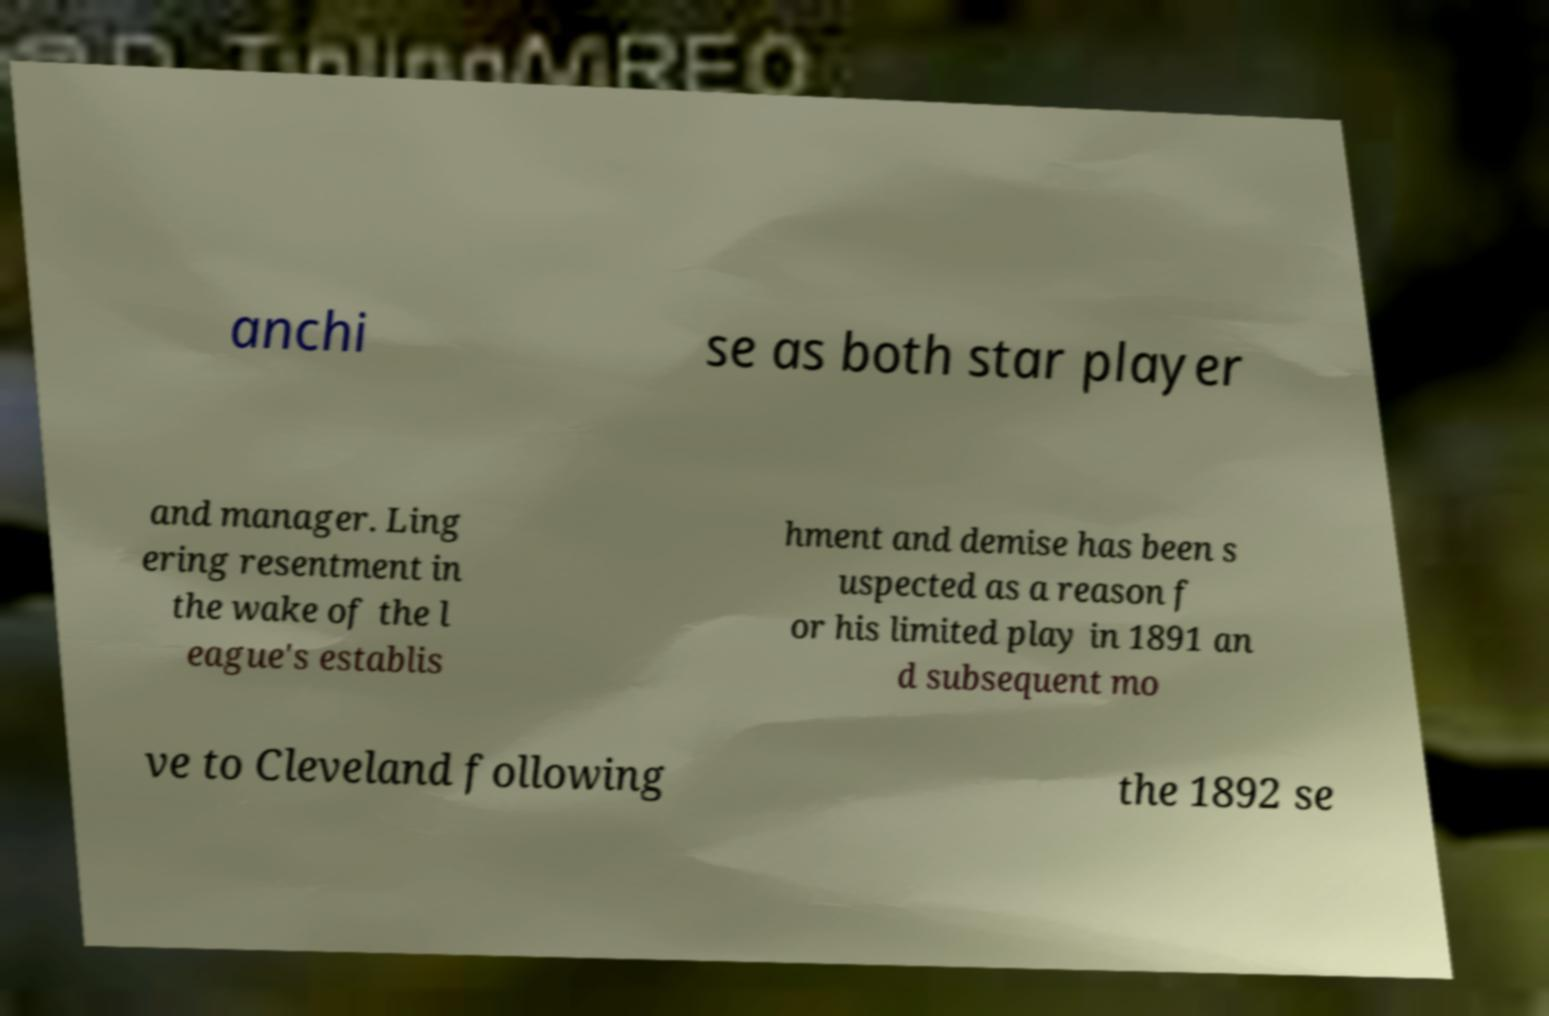What messages or text are displayed in this image? I need them in a readable, typed format. anchi se as both star player and manager. Ling ering resentment in the wake of the l eague's establis hment and demise has been s uspected as a reason f or his limited play in 1891 an d subsequent mo ve to Cleveland following the 1892 se 